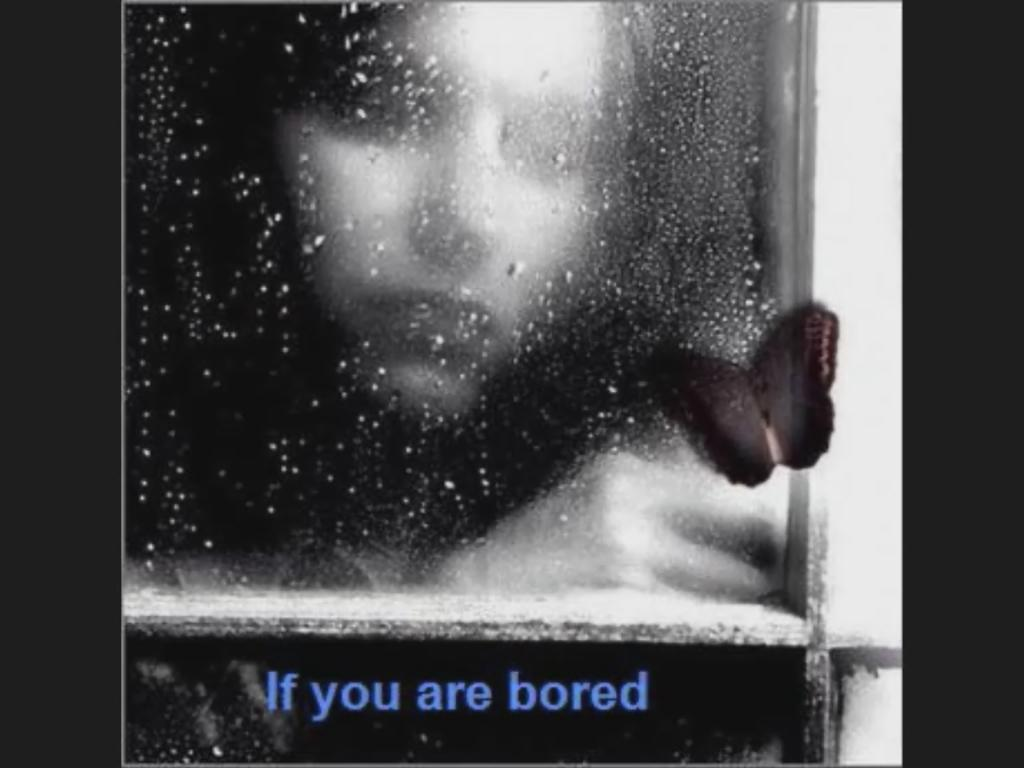What is the main subject visible in the image? There is a person visible through a glass frame in the image. Are there any other living creatures in the image? Yes, there is a butterfly in the image. What can be found at the bottom of the image? There is text at the bottom of the image. How many screws are visible in the image? There are no screws visible in the image. What type of seat is shown in the image? There is no seat present in the image. 